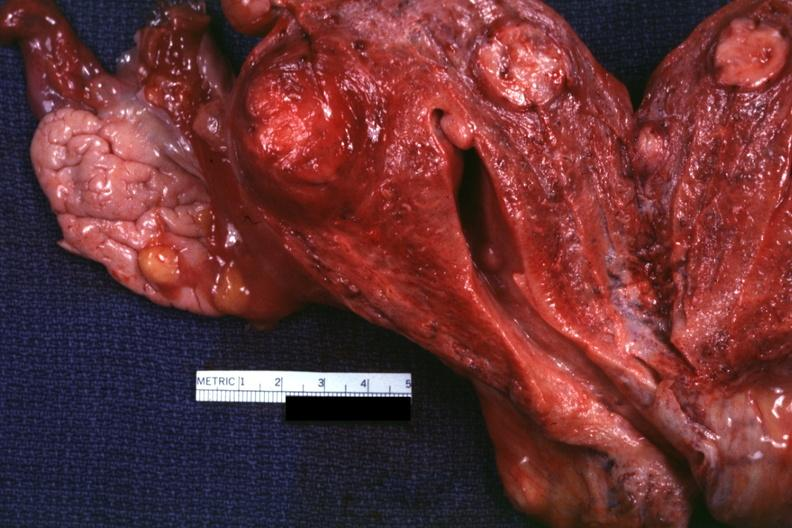what does this image show?
Answer the question using a single word or phrase. Cut surface of uterus several lesions 